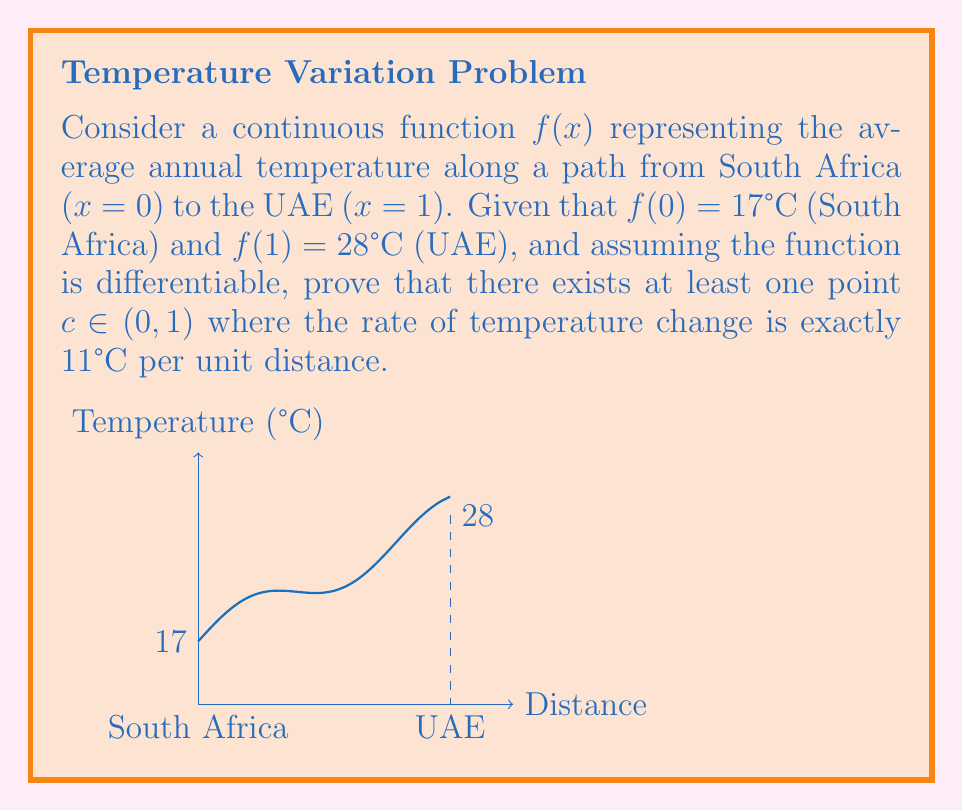Give your solution to this math problem. To prove this, we can use the Mean Value Theorem. Let's follow these steps:

1) The Mean Value Theorem states that for a function $f(x)$ that is continuous on the closed interval $[a,b]$ and differentiable on the open interval $(a,b)$, there exists at least one $c \in (a,b)$ such that:

   $$f'(c) = \frac{f(b) - f(a)}{b - a}$$

2) In our case, $a = 0$ (South Africa) and $b = 1$ (UAE). We're given that $f(0) = 17°C$ and $f(1) = 28°C$.

3) Let's calculate the right side of the equation:

   $$\frac{f(1) - f(0)}{1 - 0} = \frac{28°C - 17°C}{1 - 0} = 11°C$$

4) Therefore, according to the Mean Value Theorem, there must exist at least one point $c \in (0,1)$ where:

   $$f'(c) = 11°C$$

5) $f'(c)$ represents the instantaneous rate of change of temperature with respect to distance at point $c$. In this context, it's the rate of temperature change per unit distance.

Thus, we've proven that there exists at least one point between South Africa and the UAE where the rate of temperature change is exactly $11°C$ per unit distance.
Answer: Mean Value Theorem: $\exists c \in (0,1)$ where $f'(c) = 11°C$ per unit distance. 